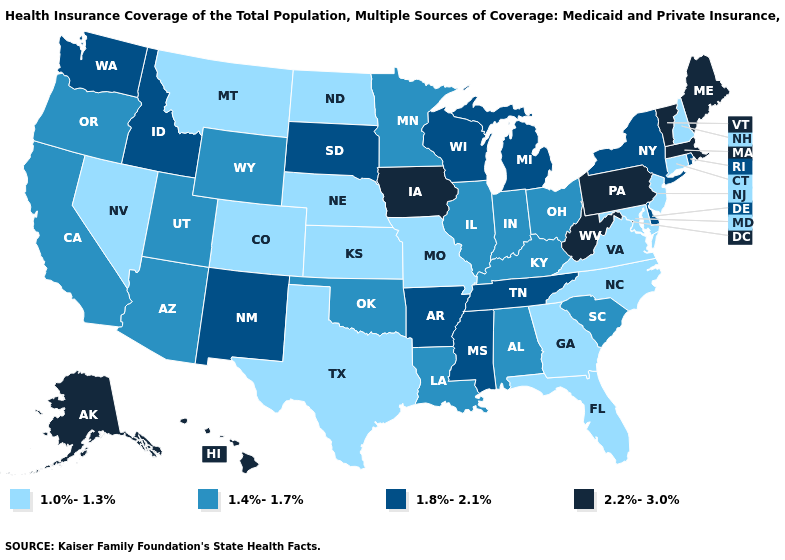What is the highest value in states that border Iowa?
Concise answer only. 1.8%-2.1%. What is the value of Vermont?
Be succinct. 2.2%-3.0%. What is the lowest value in states that border Colorado?
Keep it brief. 1.0%-1.3%. Name the states that have a value in the range 2.2%-3.0%?
Give a very brief answer. Alaska, Hawaii, Iowa, Maine, Massachusetts, Pennsylvania, Vermont, West Virginia. Which states have the highest value in the USA?
Keep it brief. Alaska, Hawaii, Iowa, Maine, Massachusetts, Pennsylvania, Vermont, West Virginia. Name the states that have a value in the range 1.8%-2.1%?
Answer briefly. Arkansas, Delaware, Idaho, Michigan, Mississippi, New Mexico, New York, Rhode Island, South Dakota, Tennessee, Washington, Wisconsin. What is the highest value in the South ?
Be succinct. 2.2%-3.0%. Name the states that have a value in the range 2.2%-3.0%?
Write a very short answer. Alaska, Hawaii, Iowa, Maine, Massachusetts, Pennsylvania, Vermont, West Virginia. What is the value of Utah?
Quick response, please. 1.4%-1.7%. Name the states that have a value in the range 1.4%-1.7%?
Keep it brief. Alabama, Arizona, California, Illinois, Indiana, Kentucky, Louisiana, Minnesota, Ohio, Oklahoma, Oregon, South Carolina, Utah, Wyoming. Does the first symbol in the legend represent the smallest category?
Be succinct. Yes. Does Maryland have a higher value than Massachusetts?
Quick response, please. No. Is the legend a continuous bar?
Concise answer only. No. Among the states that border Minnesota , does Iowa have the highest value?
Short answer required. Yes. Does Connecticut have the lowest value in the Northeast?
Answer briefly. Yes. 